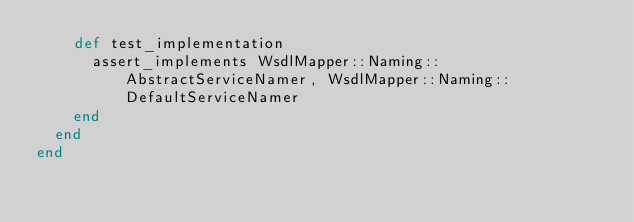<code> <loc_0><loc_0><loc_500><loc_500><_Ruby_>    def test_implementation
      assert_implements WsdlMapper::Naming::AbstractServiceNamer, WsdlMapper::Naming::DefaultServiceNamer
    end
  end
end
</code> 